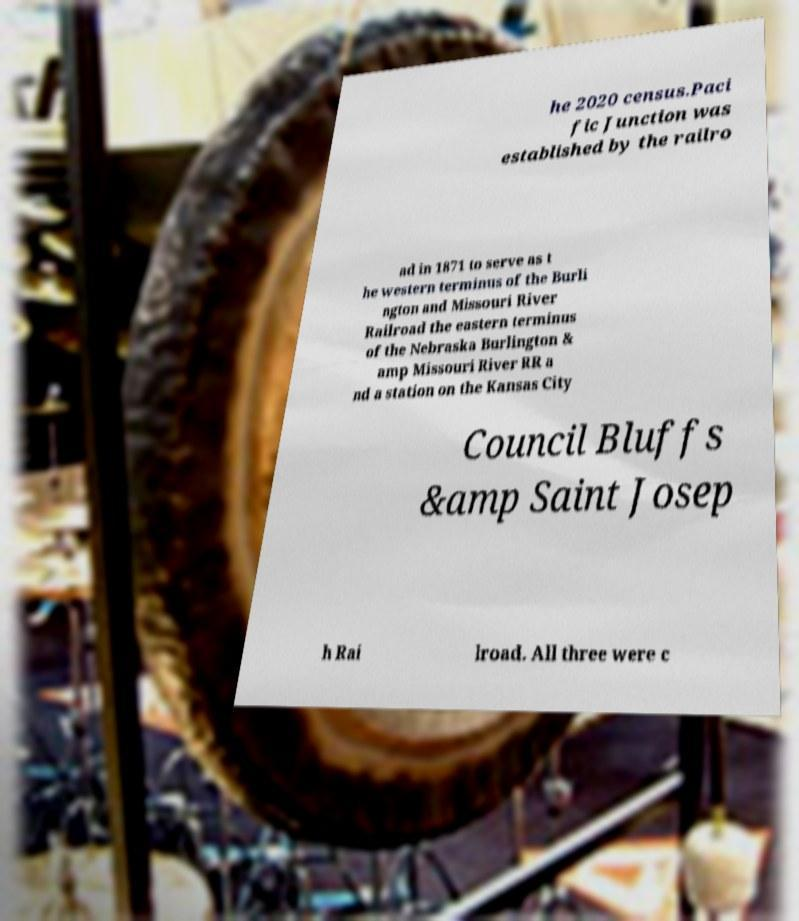There's text embedded in this image that I need extracted. Can you transcribe it verbatim? he 2020 census.Paci fic Junction was established by the railro ad in 1871 to serve as t he western terminus of the Burli ngton and Missouri River Railroad the eastern terminus of the Nebraska Burlington & amp Missouri River RR a nd a station on the Kansas City Council Bluffs &amp Saint Josep h Rai lroad. All three were c 